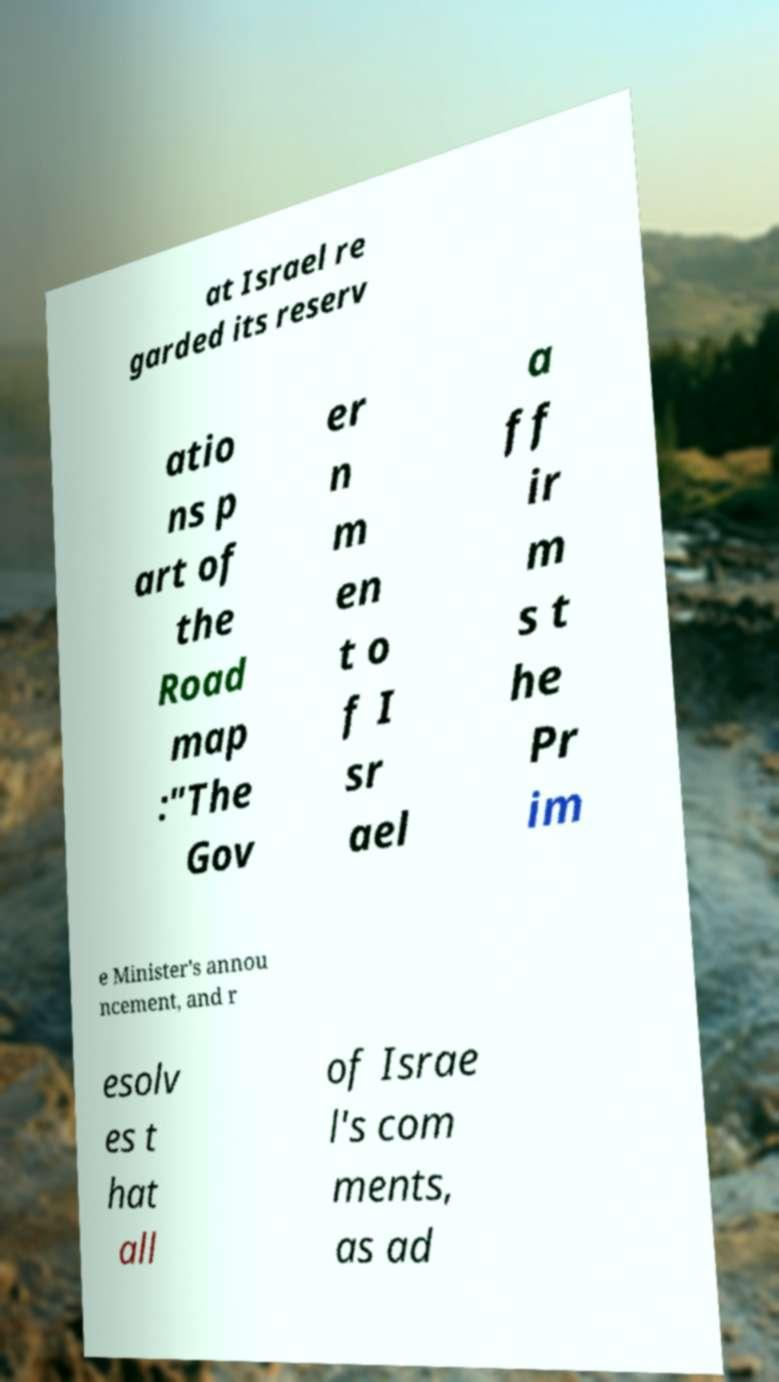For documentation purposes, I need the text within this image transcribed. Could you provide that? at Israel re garded its reserv atio ns p art of the Road map :"The Gov er n m en t o f I sr ael a ff ir m s t he Pr im e Minister's annou ncement, and r esolv es t hat all of Israe l's com ments, as ad 